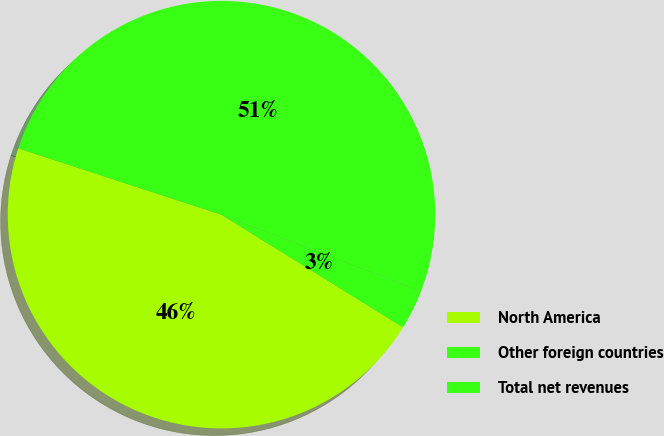Convert chart to OTSL. <chart><loc_0><loc_0><loc_500><loc_500><pie_chart><fcel>North America<fcel>Other foreign countries<fcel>Total net revenues<nl><fcel>46.19%<fcel>3.0%<fcel>50.81%<nl></chart> 